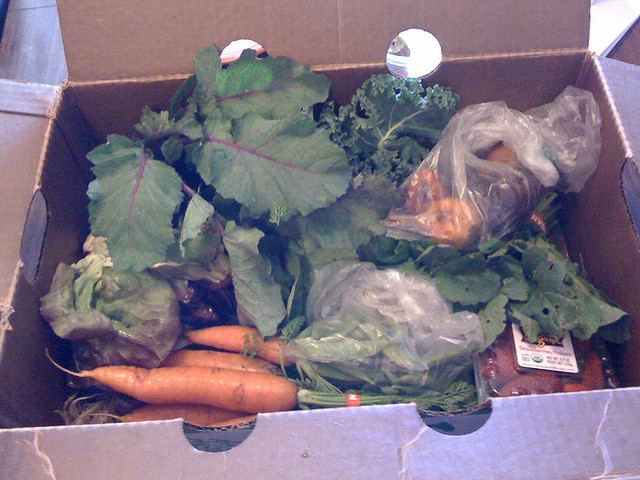Describe the objects in this image and their specific colors. I can see broccoli in blue, gray, navy, and darkgray tones, carrot in blue, salmon, and brown tones, carrot in blue, brown, salmon, and darkgray tones, carrot in blue, brown, purple, and navy tones, and carrot in blue, brown, salmon, and purple tones in this image. 